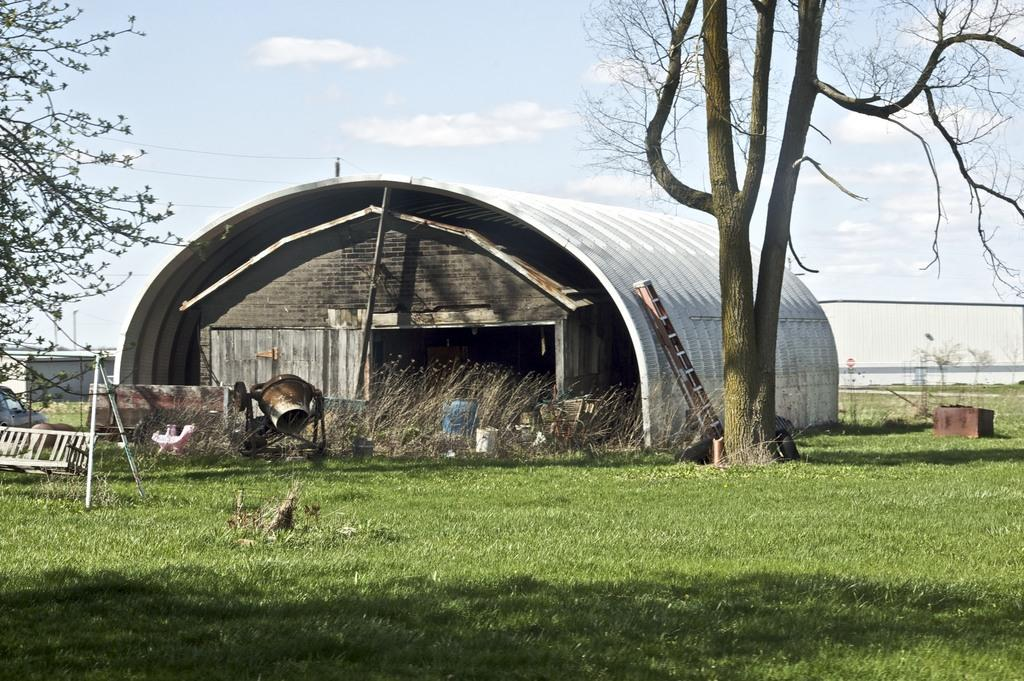What type of vegetation can be seen in the image? There is grass and trees in the image. What structures are present in the image? There are poles, a machine, a ladder, a shed, and unspecified objects in the image. What can be seen in the background of the image? There is a wall, poles, wires, sky, and clouds in the background of the image. What type of metal is used to make the collar of the dog in the image? There is no dog or collar present in the image. How do the two objects in the image engage in a fight? There are no objects engaging in a fight in the image. 